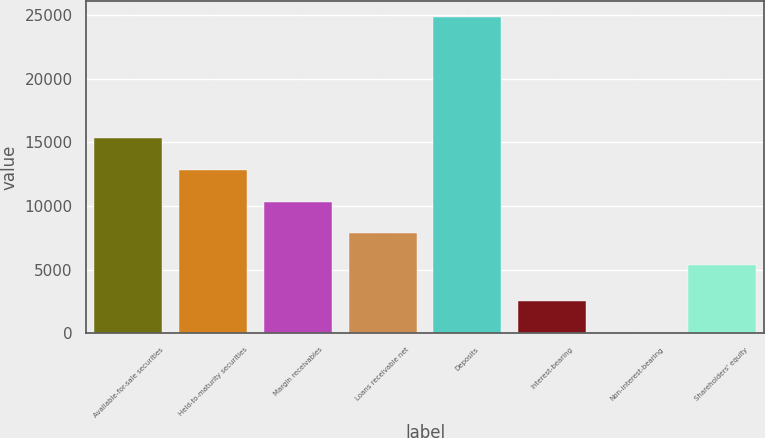Convert chart to OTSL. <chart><loc_0><loc_0><loc_500><loc_500><bar_chart><fcel>Available-for-sale securities<fcel>Held-to-maturity securities<fcel>Margin receivables<fcel>Loans receivable net<fcel>Deposits<fcel>Interest-bearing<fcel>Non-interest-bearing<fcel>Shareholders' equity<nl><fcel>15315.8<fcel>12830.6<fcel>10345.4<fcel>7860.2<fcel>24890<fcel>2523.2<fcel>38<fcel>5375<nl></chart> 